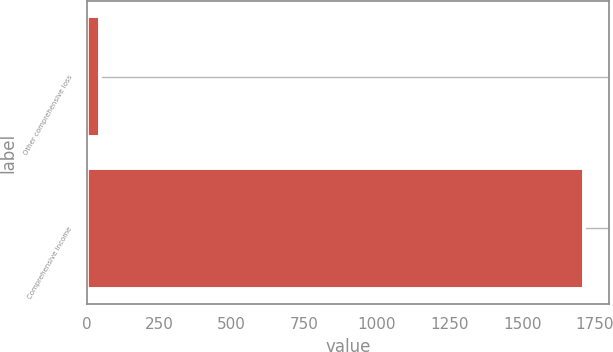Convert chart to OTSL. <chart><loc_0><loc_0><loc_500><loc_500><bar_chart><fcel>Other comprehensive loss<fcel>Comprehensive income<nl><fcel>46.6<fcel>1714.4<nl></chart> 